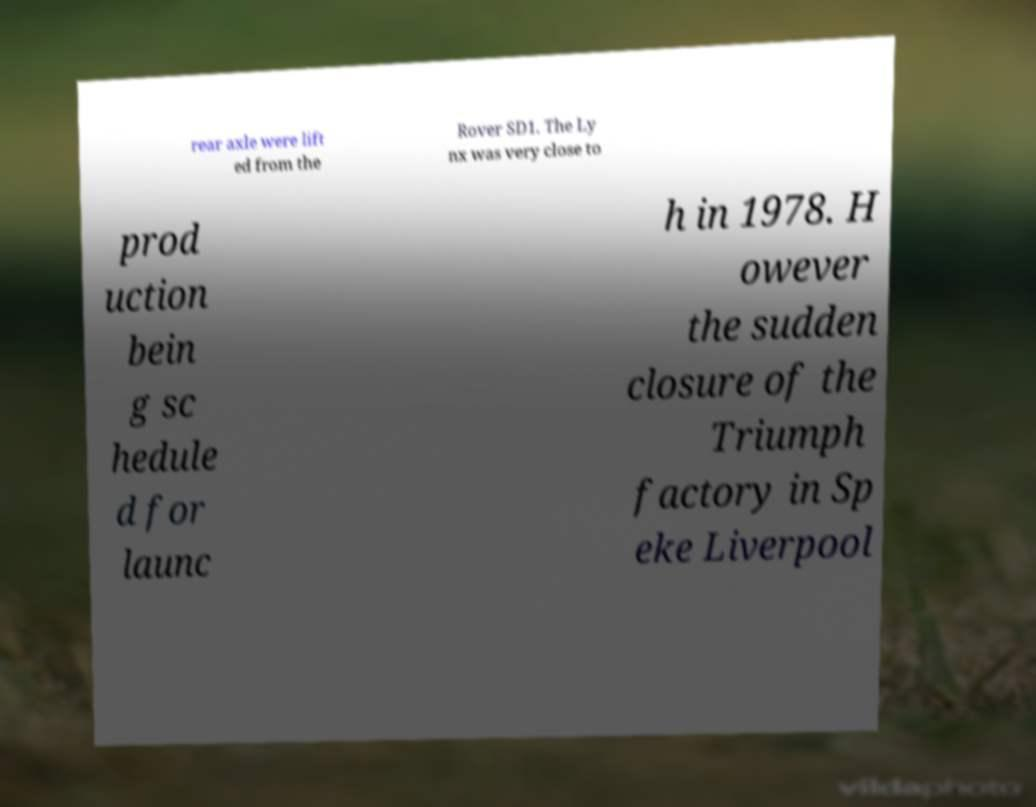Could you assist in decoding the text presented in this image and type it out clearly? rear axle were lift ed from the Rover SD1. The Ly nx was very close to prod uction bein g sc hedule d for launc h in 1978. H owever the sudden closure of the Triumph factory in Sp eke Liverpool 